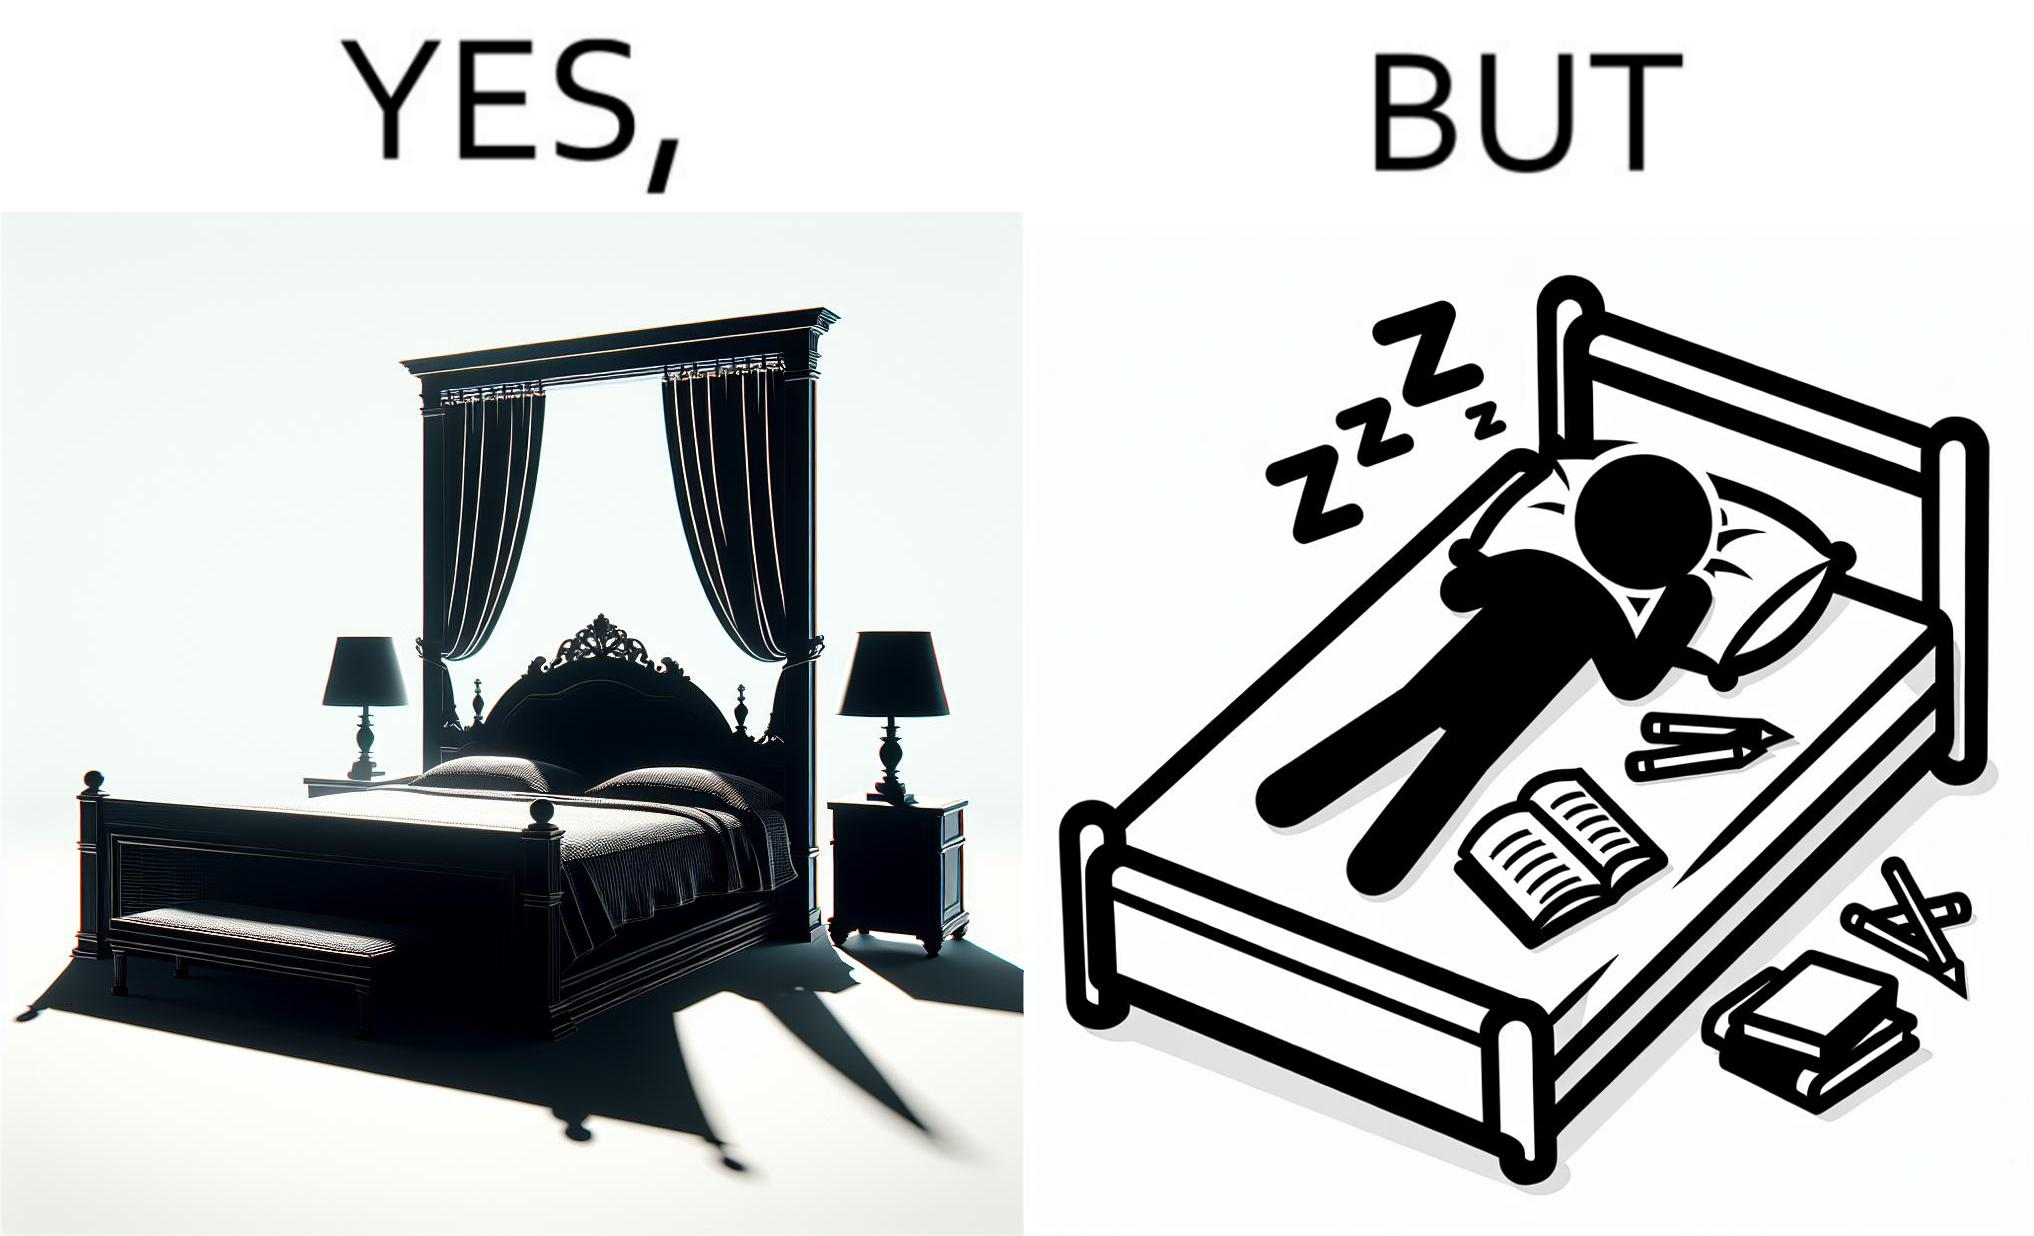Describe what you see in the left and right parts of this image. In the left part of the image: There is a bed of king size. In the right part of the image: There is a person sleeping with his material on its bed; 